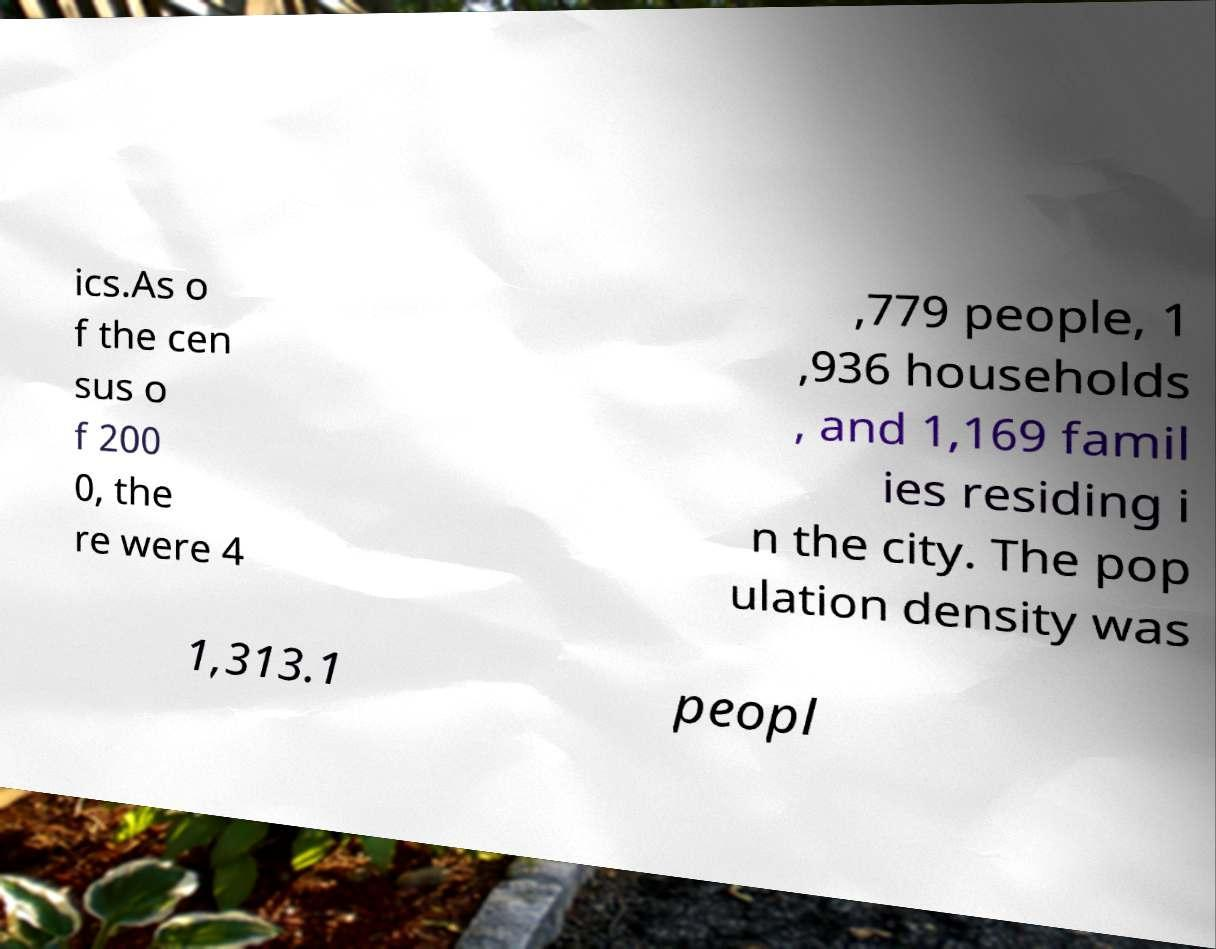Can you read and provide the text displayed in the image?This photo seems to have some interesting text. Can you extract and type it out for me? ics.As o f the cen sus o f 200 0, the re were 4 ,779 people, 1 ,936 households , and 1,169 famil ies residing i n the city. The pop ulation density was 1,313.1 peopl 